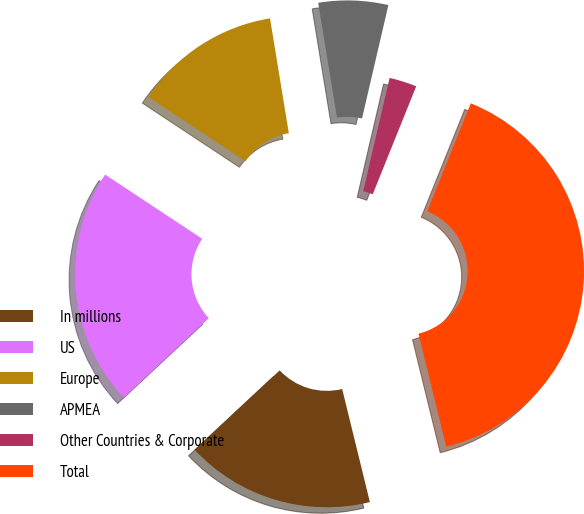Convert chart to OTSL. <chart><loc_0><loc_0><loc_500><loc_500><pie_chart><fcel>In millions<fcel>US<fcel>Europe<fcel>APMEA<fcel>Other Countries & Corporate<fcel>Total<nl><fcel>16.88%<fcel>21.24%<fcel>13.12%<fcel>6.22%<fcel>2.46%<fcel>40.08%<nl></chart> 